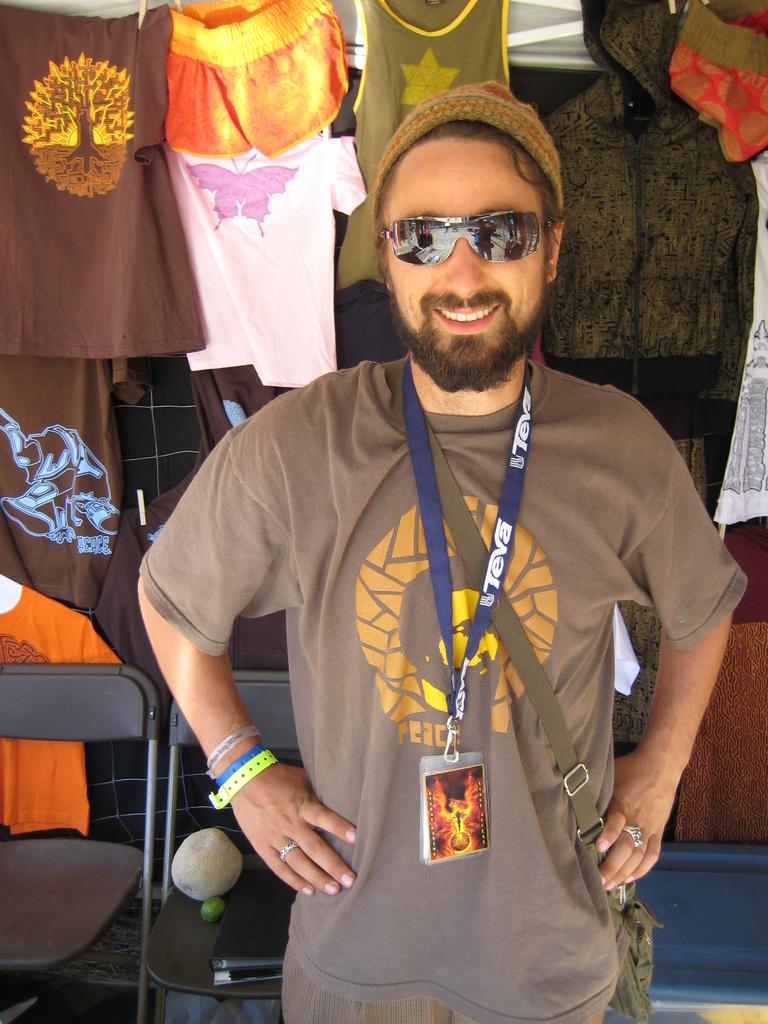What can be seen in the sky in the image? There are clouds in the image. What type of furniture is present in the image? There are chairs in the image. Who is in the image? There is a man in the image. What is the man wearing on his face? The man is wearing goggles. What is the man wearing on his head? The man is wearing a cap. What color is the man's t-shirt? The man is wearing a brown color t-shirt. Does the man have any identification in the image? Yes, the man has an ID card. What book is the man reading in the image? There is no book present in the image. Who is the manager of the man in the image? There is no manager mentioned or depicted in the image. 